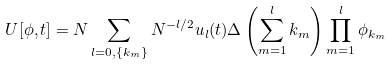<formula> <loc_0><loc_0><loc_500><loc_500>U [ { \phi } , t ] = N \sum _ { l = 0 , \{ k _ { m } \} } N ^ { - l / 2 } u _ { l } ( t ) \Delta \left ( \sum _ { m = 1 } ^ { l } { k } _ { m } \right ) \prod _ { m = 1 } ^ { l } \phi _ { { k } _ { m } }</formula> 